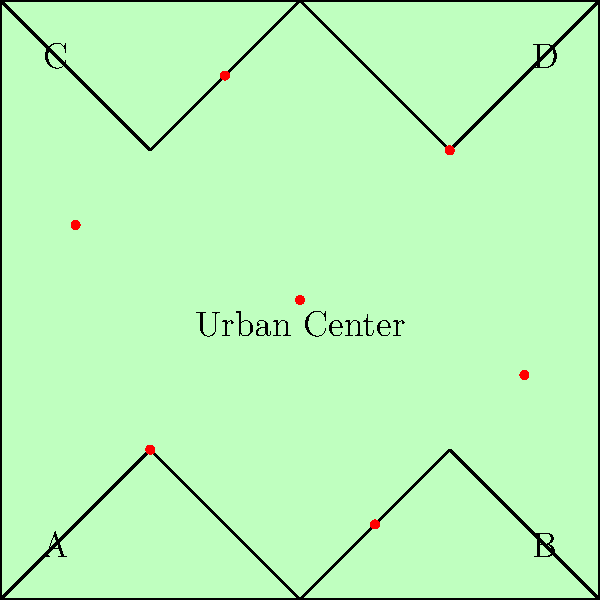Based on the map showing the distribution of veterinary practices (red dots) across different regions, which area appears to have the highest concentration of practices, and what factors might contribute to this distribution? To analyze the distribution of veterinary practices across the region, let's follow these steps:

1. Identify the regions:
   The map is divided into 5 distinct areas - a central region (Urban Center) and four surrounding regions (A, B, C, and D).

2. Count the number of practices in each region:
   - Urban Center: 1 practice
   - Region A: 1 practice
   - Region B: 2 practices
   - Region C: 2 practices
   - Region D: 1 practice

3. Analyze the concentration:
   The highest concentration appears to be in the Urban Center and its immediate surroundings. While the Urban Center itself has only one practice, it's centrally located with easy access to practices in all surrounding regions.

4. Consider contributing factors:
   a) Population density: Urban areas typically have higher population densities, which could support more veterinary practices.
   b) Accessibility: The central location provides good accessibility for clients from all regions.
   c) Mixed practice opportunities: Proximity to both urban and rural areas allows for a diverse client base (pets and farm animals).
   d) Economic factors: Urban areas often have higher income levels, potentially supporting more frequent veterinary care.
   e) Livestock concentration: Regions B and C have slightly more practices, which could indicate higher livestock populations in these areas.

5. Conclusion:
   While no single region has a significantly higher number of practices, the Urban Center and its surrounding areas collectively show the highest concentration. This distribution likely reflects a balance between serving urban pet owners and rural livestock farmers.
Answer: Urban Center and surrounding areas; balances urban and rural veterinary needs. 